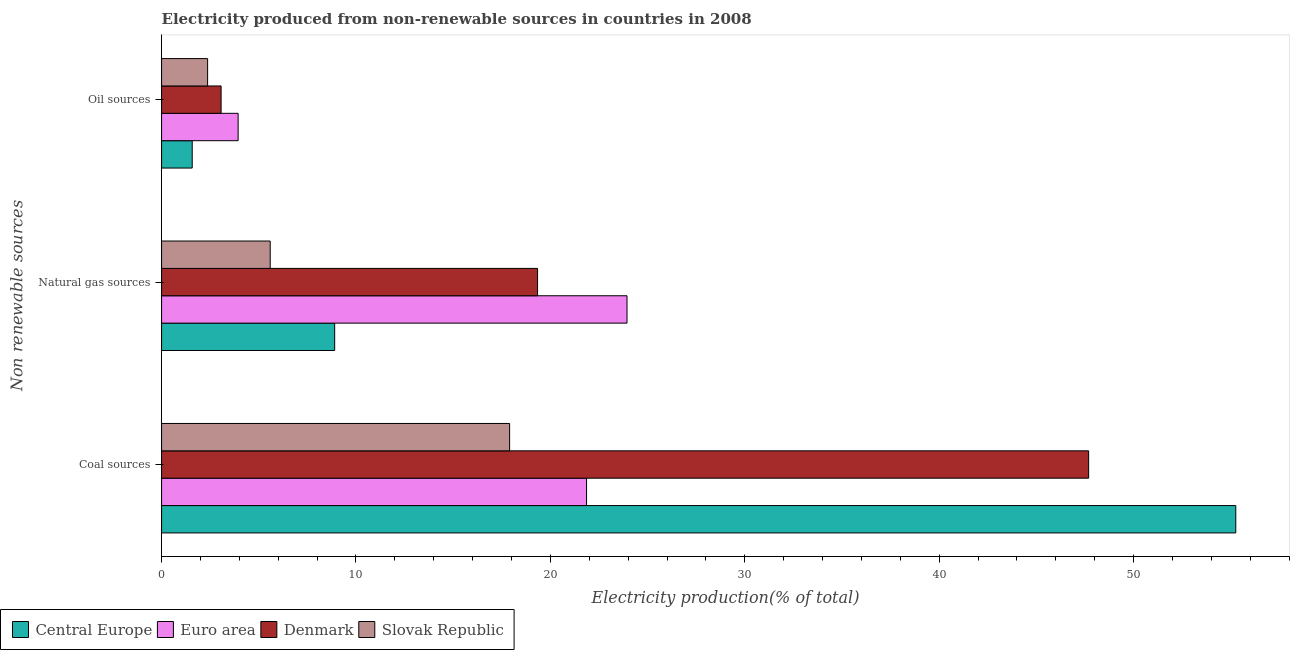How many groups of bars are there?
Your response must be concise. 3. How many bars are there on the 3rd tick from the top?
Give a very brief answer. 4. How many bars are there on the 1st tick from the bottom?
Ensure brevity in your answer.  4. What is the label of the 3rd group of bars from the top?
Provide a succinct answer. Coal sources. What is the percentage of electricity produced by oil sources in Denmark?
Provide a succinct answer. 3.06. Across all countries, what is the maximum percentage of electricity produced by coal?
Offer a terse response. 55.26. Across all countries, what is the minimum percentage of electricity produced by natural gas?
Give a very brief answer. 5.59. In which country was the percentage of electricity produced by natural gas maximum?
Keep it short and to the point. Euro area. In which country was the percentage of electricity produced by natural gas minimum?
Your answer should be compact. Slovak Republic. What is the total percentage of electricity produced by oil sources in the graph?
Make the answer very short. 10.94. What is the difference between the percentage of electricity produced by natural gas in Euro area and that in Denmark?
Your response must be concise. 4.6. What is the difference between the percentage of electricity produced by oil sources in Denmark and the percentage of electricity produced by natural gas in Central Europe?
Offer a terse response. -5.84. What is the average percentage of electricity produced by oil sources per country?
Your response must be concise. 2.74. What is the difference between the percentage of electricity produced by oil sources and percentage of electricity produced by coal in Central Europe?
Keep it short and to the point. -53.68. In how many countries, is the percentage of electricity produced by oil sources greater than 10 %?
Give a very brief answer. 0. What is the ratio of the percentage of electricity produced by natural gas in Denmark to that in Central Europe?
Your answer should be compact. 2.17. What is the difference between the highest and the second highest percentage of electricity produced by coal?
Offer a terse response. 7.57. What is the difference between the highest and the lowest percentage of electricity produced by coal?
Offer a very short reply. 37.36. What does the 4th bar from the top in Natural gas sources represents?
Offer a terse response. Central Europe. What does the 4th bar from the bottom in Natural gas sources represents?
Your answer should be very brief. Slovak Republic. Are all the bars in the graph horizontal?
Provide a succinct answer. Yes. Does the graph contain any zero values?
Your response must be concise. No. Does the graph contain grids?
Ensure brevity in your answer.  No. Where does the legend appear in the graph?
Offer a very short reply. Bottom left. How many legend labels are there?
Offer a terse response. 4. What is the title of the graph?
Offer a terse response. Electricity produced from non-renewable sources in countries in 2008. What is the label or title of the X-axis?
Keep it short and to the point. Electricity production(% of total). What is the label or title of the Y-axis?
Make the answer very short. Non renewable sources. What is the Electricity production(% of total) of Central Europe in Coal sources?
Keep it short and to the point. 55.26. What is the Electricity production(% of total) in Euro area in Coal sources?
Ensure brevity in your answer.  21.86. What is the Electricity production(% of total) of Denmark in Coal sources?
Your response must be concise. 47.69. What is the Electricity production(% of total) in Slovak Republic in Coal sources?
Offer a very short reply. 17.9. What is the Electricity production(% of total) in Central Europe in Natural gas sources?
Provide a short and direct response. 8.9. What is the Electricity production(% of total) of Euro area in Natural gas sources?
Offer a very short reply. 23.94. What is the Electricity production(% of total) in Denmark in Natural gas sources?
Offer a very short reply. 19.34. What is the Electricity production(% of total) in Slovak Republic in Natural gas sources?
Your answer should be compact. 5.59. What is the Electricity production(% of total) of Central Europe in Oil sources?
Give a very brief answer. 1.58. What is the Electricity production(% of total) of Euro area in Oil sources?
Your answer should be compact. 3.94. What is the Electricity production(% of total) in Denmark in Oil sources?
Keep it short and to the point. 3.06. What is the Electricity production(% of total) of Slovak Republic in Oil sources?
Provide a short and direct response. 2.37. Across all Non renewable sources, what is the maximum Electricity production(% of total) of Central Europe?
Provide a short and direct response. 55.26. Across all Non renewable sources, what is the maximum Electricity production(% of total) in Euro area?
Provide a short and direct response. 23.94. Across all Non renewable sources, what is the maximum Electricity production(% of total) of Denmark?
Offer a terse response. 47.69. Across all Non renewable sources, what is the maximum Electricity production(% of total) of Slovak Republic?
Offer a very short reply. 17.9. Across all Non renewable sources, what is the minimum Electricity production(% of total) in Central Europe?
Make the answer very short. 1.58. Across all Non renewable sources, what is the minimum Electricity production(% of total) of Euro area?
Offer a very short reply. 3.94. Across all Non renewable sources, what is the minimum Electricity production(% of total) in Denmark?
Your answer should be compact. 3.06. Across all Non renewable sources, what is the minimum Electricity production(% of total) of Slovak Republic?
Offer a terse response. 2.37. What is the total Electricity production(% of total) in Central Europe in the graph?
Provide a succinct answer. 65.74. What is the total Electricity production(% of total) of Euro area in the graph?
Your answer should be compact. 49.74. What is the total Electricity production(% of total) in Denmark in the graph?
Keep it short and to the point. 70.09. What is the total Electricity production(% of total) in Slovak Republic in the graph?
Your answer should be very brief. 25.86. What is the difference between the Electricity production(% of total) in Central Europe in Coal sources and that in Natural gas sources?
Keep it short and to the point. 46.35. What is the difference between the Electricity production(% of total) of Euro area in Coal sources and that in Natural gas sources?
Offer a terse response. -2.08. What is the difference between the Electricity production(% of total) of Denmark in Coal sources and that in Natural gas sources?
Give a very brief answer. 28.35. What is the difference between the Electricity production(% of total) of Slovak Republic in Coal sources and that in Natural gas sources?
Give a very brief answer. 12.32. What is the difference between the Electricity production(% of total) of Central Europe in Coal sources and that in Oil sources?
Your response must be concise. 53.68. What is the difference between the Electricity production(% of total) of Euro area in Coal sources and that in Oil sources?
Provide a short and direct response. 17.92. What is the difference between the Electricity production(% of total) in Denmark in Coal sources and that in Oil sources?
Offer a terse response. 44.63. What is the difference between the Electricity production(% of total) in Slovak Republic in Coal sources and that in Oil sources?
Make the answer very short. 15.54. What is the difference between the Electricity production(% of total) in Central Europe in Natural gas sources and that in Oil sources?
Offer a very short reply. 7.33. What is the difference between the Electricity production(% of total) in Euro area in Natural gas sources and that in Oil sources?
Your answer should be very brief. 20. What is the difference between the Electricity production(% of total) in Denmark in Natural gas sources and that in Oil sources?
Keep it short and to the point. 16.28. What is the difference between the Electricity production(% of total) of Slovak Republic in Natural gas sources and that in Oil sources?
Provide a succinct answer. 3.22. What is the difference between the Electricity production(% of total) in Central Europe in Coal sources and the Electricity production(% of total) in Euro area in Natural gas sources?
Your response must be concise. 31.32. What is the difference between the Electricity production(% of total) of Central Europe in Coal sources and the Electricity production(% of total) of Denmark in Natural gas sources?
Keep it short and to the point. 35.92. What is the difference between the Electricity production(% of total) of Central Europe in Coal sources and the Electricity production(% of total) of Slovak Republic in Natural gas sources?
Give a very brief answer. 49.67. What is the difference between the Electricity production(% of total) in Euro area in Coal sources and the Electricity production(% of total) in Denmark in Natural gas sources?
Ensure brevity in your answer.  2.52. What is the difference between the Electricity production(% of total) of Euro area in Coal sources and the Electricity production(% of total) of Slovak Republic in Natural gas sources?
Ensure brevity in your answer.  16.27. What is the difference between the Electricity production(% of total) in Denmark in Coal sources and the Electricity production(% of total) in Slovak Republic in Natural gas sources?
Keep it short and to the point. 42.1. What is the difference between the Electricity production(% of total) in Central Europe in Coal sources and the Electricity production(% of total) in Euro area in Oil sources?
Offer a very short reply. 51.32. What is the difference between the Electricity production(% of total) of Central Europe in Coal sources and the Electricity production(% of total) of Denmark in Oil sources?
Make the answer very short. 52.2. What is the difference between the Electricity production(% of total) in Central Europe in Coal sources and the Electricity production(% of total) in Slovak Republic in Oil sources?
Provide a short and direct response. 52.89. What is the difference between the Electricity production(% of total) of Euro area in Coal sources and the Electricity production(% of total) of Denmark in Oil sources?
Give a very brief answer. 18.8. What is the difference between the Electricity production(% of total) in Euro area in Coal sources and the Electricity production(% of total) in Slovak Republic in Oil sources?
Provide a short and direct response. 19.49. What is the difference between the Electricity production(% of total) in Denmark in Coal sources and the Electricity production(% of total) in Slovak Republic in Oil sources?
Make the answer very short. 45.32. What is the difference between the Electricity production(% of total) of Central Europe in Natural gas sources and the Electricity production(% of total) of Euro area in Oil sources?
Provide a short and direct response. 4.97. What is the difference between the Electricity production(% of total) of Central Europe in Natural gas sources and the Electricity production(% of total) of Denmark in Oil sources?
Ensure brevity in your answer.  5.84. What is the difference between the Electricity production(% of total) of Central Europe in Natural gas sources and the Electricity production(% of total) of Slovak Republic in Oil sources?
Provide a succinct answer. 6.54. What is the difference between the Electricity production(% of total) of Euro area in Natural gas sources and the Electricity production(% of total) of Denmark in Oil sources?
Your answer should be compact. 20.88. What is the difference between the Electricity production(% of total) in Euro area in Natural gas sources and the Electricity production(% of total) in Slovak Republic in Oil sources?
Offer a terse response. 21.58. What is the difference between the Electricity production(% of total) of Denmark in Natural gas sources and the Electricity production(% of total) of Slovak Republic in Oil sources?
Your answer should be compact. 16.97. What is the average Electricity production(% of total) in Central Europe per Non renewable sources?
Make the answer very short. 21.91. What is the average Electricity production(% of total) in Euro area per Non renewable sources?
Your response must be concise. 16.58. What is the average Electricity production(% of total) of Denmark per Non renewable sources?
Your answer should be very brief. 23.36. What is the average Electricity production(% of total) of Slovak Republic per Non renewable sources?
Provide a short and direct response. 8.62. What is the difference between the Electricity production(% of total) in Central Europe and Electricity production(% of total) in Euro area in Coal sources?
Ensure brevity in your answer.  33.4. What is the difference between the Electricity production(% of total) of Central Europe and Electricity production(% of total) of Denmark in Coal sources?
Offer a terse response. 7.57. What is the difference between the Electricity production(% of total) of Central Europe and Electricity production(% of total) of Slovak Republic in Coal sources?
Provide a succinct answer. 37.36. What is the difference between the Electricity production(% of total) in Euro area and Electricity production(% of total) in Denmark in Coal sources?
Your answer should be compact. -25.83. What is the difference between the Electricity production(% of total) in Euro area and Electricity production(% of total) in Slovak Republic in Coal sources?
Provide a short and direct response. 3.96. What is the difference between the Electricity production(% of total) in Denmark and Electricity production(% of total) in Slovak Republic in Coal sources?
Your answer should be compact. 29.79. What is the difference between the Electricity production(% of total) of Central Europe and Electricity production(% of total) of Euro area in Natural gas sources?
Offer a very short reply. -15.04. What is the difference between the Electricity production(% of total) of Central Europe and Electricity production(% of total) of Denmark in Natural gas sources?
Offer a very short reply. -10.44. What is the difference between the Electricity production(% of total) of Central Europe and Electricity production(% of total) of Slovak Republic in Natural gas sources?
Give a very brief answer. 3.32. What is the difference between the Electricity production(% of total) in Euro area and Electricity production(% of total) in Denmark in Natural gas sources?
Offer a terse response. 4.6. What is the difference between the Electricity production(% of total) in Euro area and Electricity production(% of total) in Slovak Republic in Natural gas sources?
Make the answer very short. 18.36. What is the difference between the Electricity production(% of total) of Denmark and Electricity production(% of total) of Slovak Republic in Natural gas sources?
Keep it short and to the point. 13.75. What is the difference between the Electricity production(% of total) in Central Europe and Electricity production(% of total) in Euro area in Oil sources?
Your answer should be very brief. -2.36. What is the difference between the Electricity production(% of total) of Central Europe and Electricity production(% of total) of Denmark in Oil sources?
Provide a short and direct response. -1.49. What is the difference between the Electricity production(% of total) of Central Europe and Electricity production(% of total) of Slovak Republic in Oil sources?
Your response must be concise. -0.79. What is the difference between the Electricity production(% of total) of Euro area and Electricity production(% of total) of Denmark in Oil sources?
Your response must be concise. 0.88. What is the difference between the Electricity production(% of total) of Euro area and Electricity production(% of total) of Slovak Republic in Oil sources?
Provide a short and direct response. 1.57. What is the difference between the Electricity production(% of total) in Denmark and Electricity production(% of total) in Slovak Republic in Oil sources?
Offer a very short reply. 0.69. What is the ratio of the Electricity production(% of total) in Central Europe in Coal sources to that in Natural gas sources?
Your answer should be compact. 6.21. What is the ratio of the Electricity production(% of total) in Denmark in Coal sources to that in Natural gas sources?
Give a very brief answer. 2.47. What is the ratio of the Electricity production(% of total) in Slovak Republic in Coal sources to that in Natural gas sources?
Offer a very short reply. 3.2. What is the ratio of the Electricity production(% of total) of Central Europe in Coal sources to that in Oil sources?
Keep it short and to the point. 35.05. What is the ratio of the Electricity production(% of total) of Euro area in Coal sources to that in Oil sources?
Your answer should be very brief. 5.55. What is the ratio of the Electricity production(% of total) of Denmark in Coal sources to that in Oil sources?
Ensure brevity in your answer.  15.58. What is the ratio of the Electricity production(% of total) of Slovak Republic in Coal sources to that in Oil sources?
Your response must be concise. 7.56. What is the ratio of the Electricity production(% of total) in Central Europe in Natural gas sources to that in Oil sources?
Keep it short and to the point. 5.65. What is the ratio of the Electricity production(% of total) of Euro area in Natural gas sources to that in Oil sources?
Offer a terse response. 6.08. What is the ratio of the Electricity production(% of total) in Denmark in Natural gas sources to that in Oil sources?
Make the answer very short. 6.32. What is the ratio of the Electricity production(% of total) in Slovak Republic in Natural gas sources to that in Oil sources?
Provide a succinct answer. 2.36. What is the difference between the highest and the second highest Electricity production(% of total) of Central Europe?
Make the answer very short. 46.35. What is the difference between the highest and the second highest Electricity production(% of total) in Euro area?
Offer a terse response. 2.08. What is the difference between the highest and the second highest Electricity production(% of total) in Denmark?
Ensure brevity in your answer.  28.35. What is the difference between the highest and the second highest Electricity production(% of total) of Slovak Republic?
Offer a terse response. 12.32. What is the difference between the highest and the lowest Electricity production(% of total) in Central Europe?
Ensure brevity in your answer.  53.68. What is the difference between the highest and the lowest Electricity production(% of total) of Euro area?
Make the answer very short. 20. What is the difference between the highest and the lowest Electricity production(% of total) of Denmark?
Your response must be concise. 44.63. What is the difference between the highest and the lowest Electricity production(% of total) of Slovak Republic?
Make the answer very short. 15.54. 